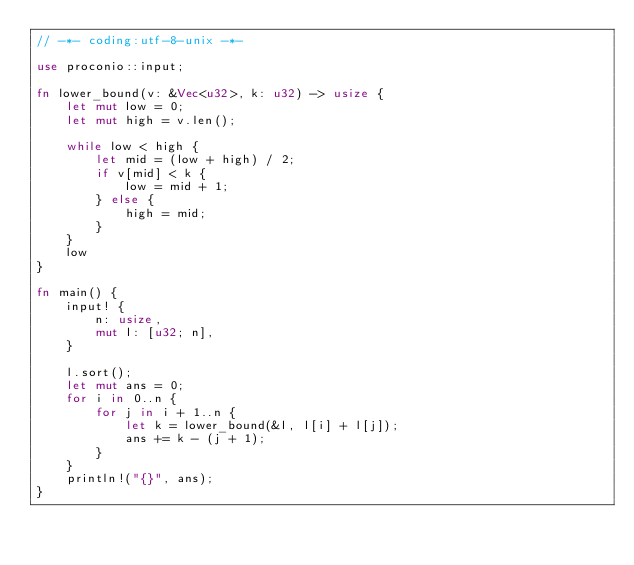<code> <loc_0><loc_0><loc_500><loc_500><_Rust_>// -*- coding:utf-8-unix -*-

use proconio::input;

fn lower_bound(v: &Vec<u32>, k: u32) -> usize {
    let mut low = 0;
    let mut high = v.len();

    while low < high {
        let mid = (low + high) / 2;
        if v[mid] < k {
            low = mid + 1;
        } else {
            high = mid;
        }
    }
    low
}

fn main() {
    input! {
        n: usize,
        mut l: [u32; n],
    }

    l.sort();
    let mut ans = 0;
    for i in 0..n {
        for j in i + 1..n {
            let k = lower_bound(&l, l[i] + l[j]);
            ans += k - (j + 1);
        }
    }
    println!("{}", ans);
}
</code> 